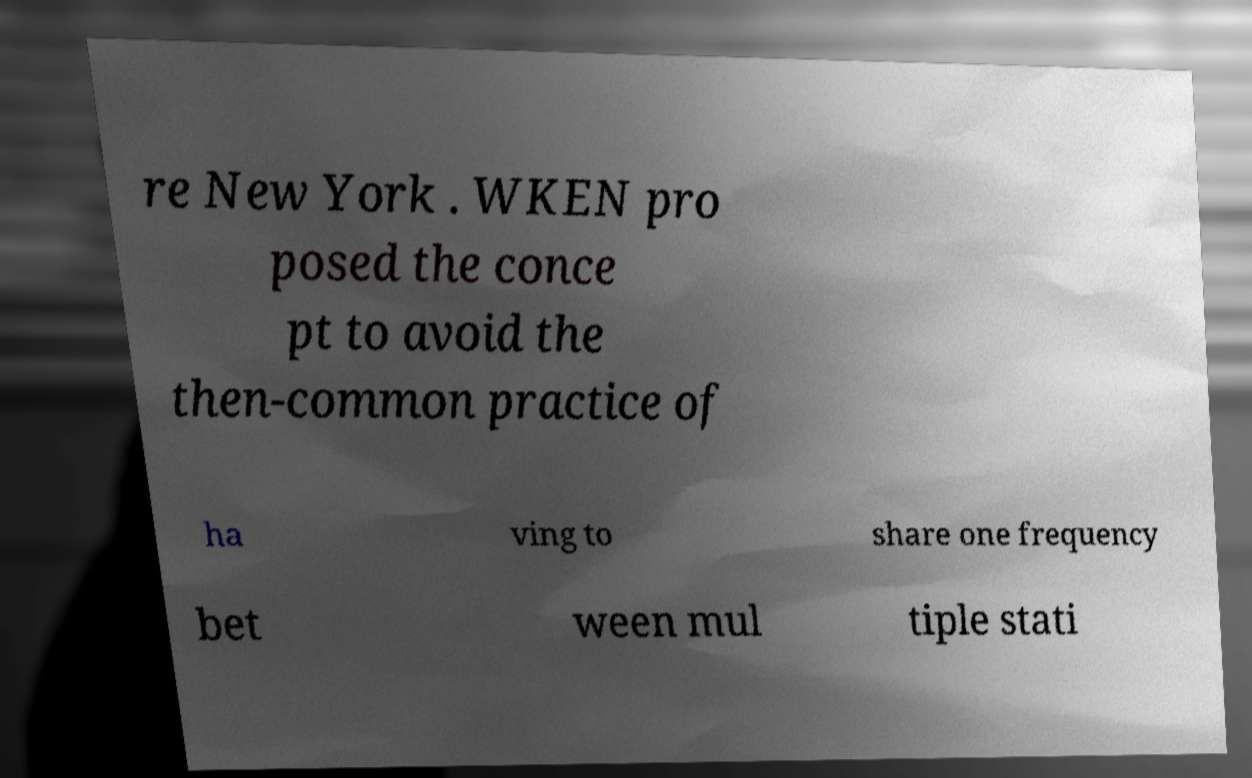Please identify and transcribe the text found in this image. re New York . WKEN pro posed the conce pt to avoid the then-common practice of ha ving to share one frequency bet ween mul tiple stati 